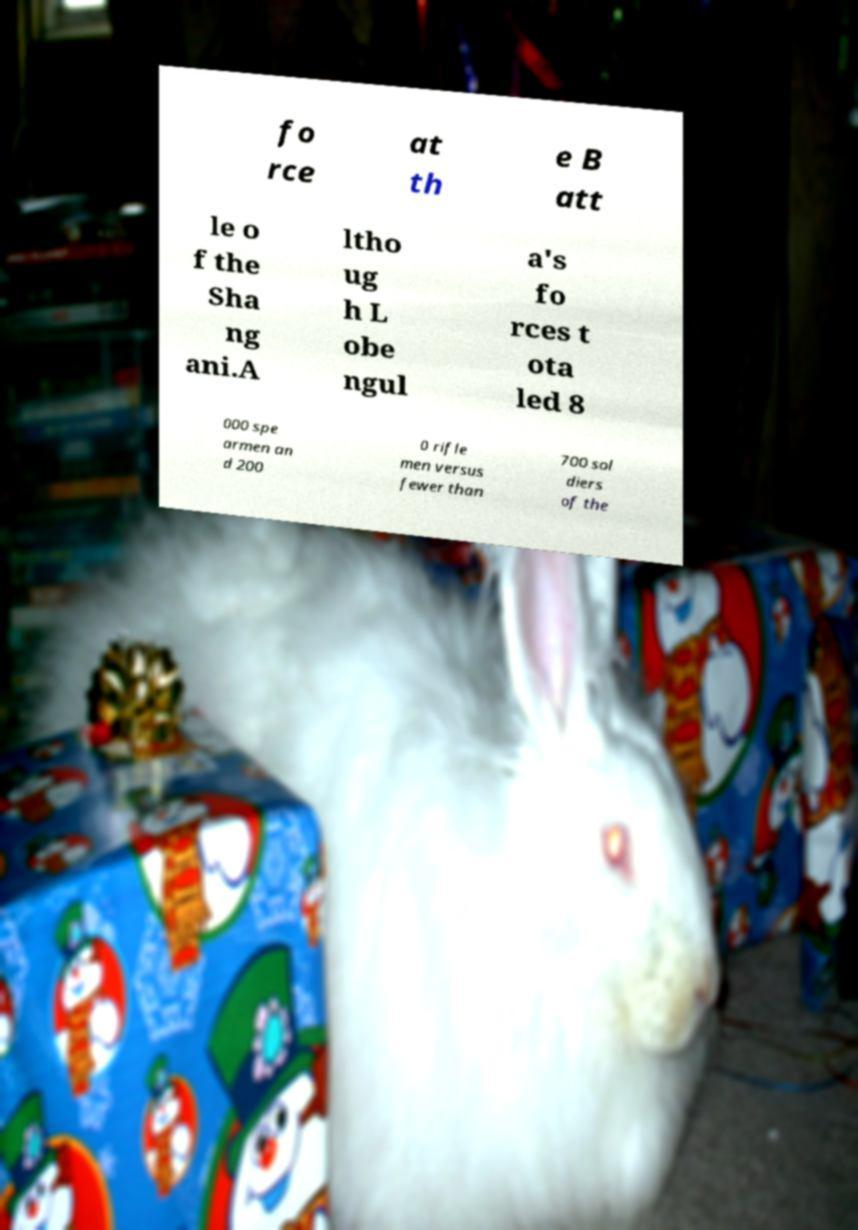For documentation purposes, I need the text within this image transcribed. Could you provide that? fo rce at th e B att le o f the Sha ng ani.A ltho ug h L obe ngul a's fo rces t ota led 8 000 spe armen an d 200 0 rifle men versus fewer than 700 sol diers of the 